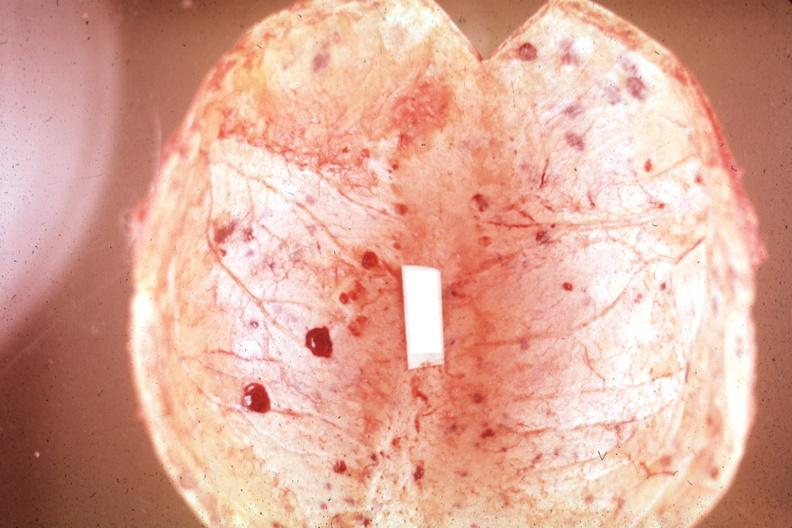what does this image show?
Answer the question using a single word or phrase. Not the best color in photo 